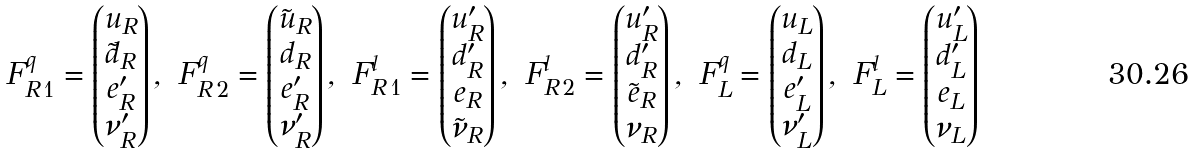<formula> <loc_0><loc_0><loc_500><loc_500>F ^ { q } _ { R \, 1 } = \begin{pmatrix} u _ { R } \\ \tilde { d } _ { R } \\ e _ { R } ^ { \prime } \\ \nu _ { R } ^ { \prime } \\ \end{pmatrix} , \ F ^ { q } _ { R \, 2 } = \begin{pmatrix} \tilde { u } _ { R } \\ d _ { R } \\ e _ { R } ^ { \prime } \\ \nu _ { R } ^ { \prime } \\ \end{pmatrix} , \ F ^ { l } _ { R \, 1 } = \begin{pmatrix} u _ { R } ^ { \prime } \\ d _ { R } ^ { \prime } \\ e _ { R } \\ \tilde { \nu } _ { R } \\ \end{pmatrix} , \ F ^ { l } _ { R \, 2 } = \begin{pmatrix} u _ { R } ^ { \prime } \\ d _ { R } ^ { \prime } \\ \tilde { e } _ { R } \\ \nu _ { R } \\ \end{pmatrix} , \ F ^ { q } _ { L } = \begin{pmatrix} u _ { L } \\ d _ { L } \\ e ^ { \prime } _ { L } \\ \nu ^ { \prime } _ { L } \\ \end{pmatrix} , \ F ^ { l } _ { L } = \begin{pmatrix} u ^ { \prime } _ { L } \\ d ^ { \prime } _ { L } \\ e _ { L } \\ \nu _ { L } \\ \end{pmatrix}</formula> 